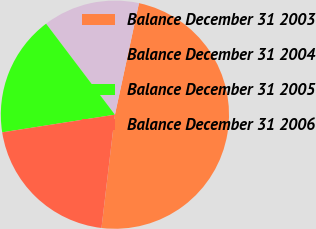Convert chart. <chart><loc_0><loc_0><loc_500><loc_500><pie_chart><fcel>Balance December 31 2003<fcel>Balance December 31 2004<fcel>Balance December 31 2005<fcel>Balance December 31 2006<nl><fcel>48.5%<fcel>13.69%<fcel>17.17%<fcel>20.65%<nl></chart> 